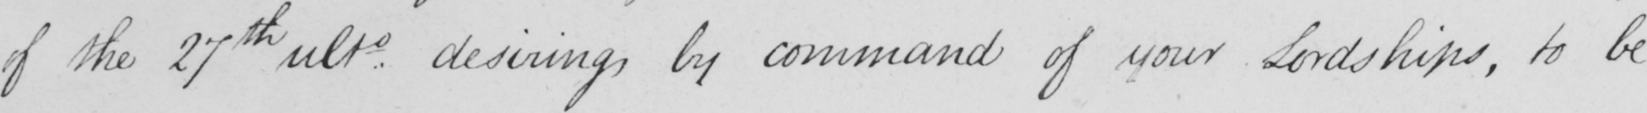What is written in this line of handwriting? of the 27th ultie desiring , by command of your Lordships , to be 